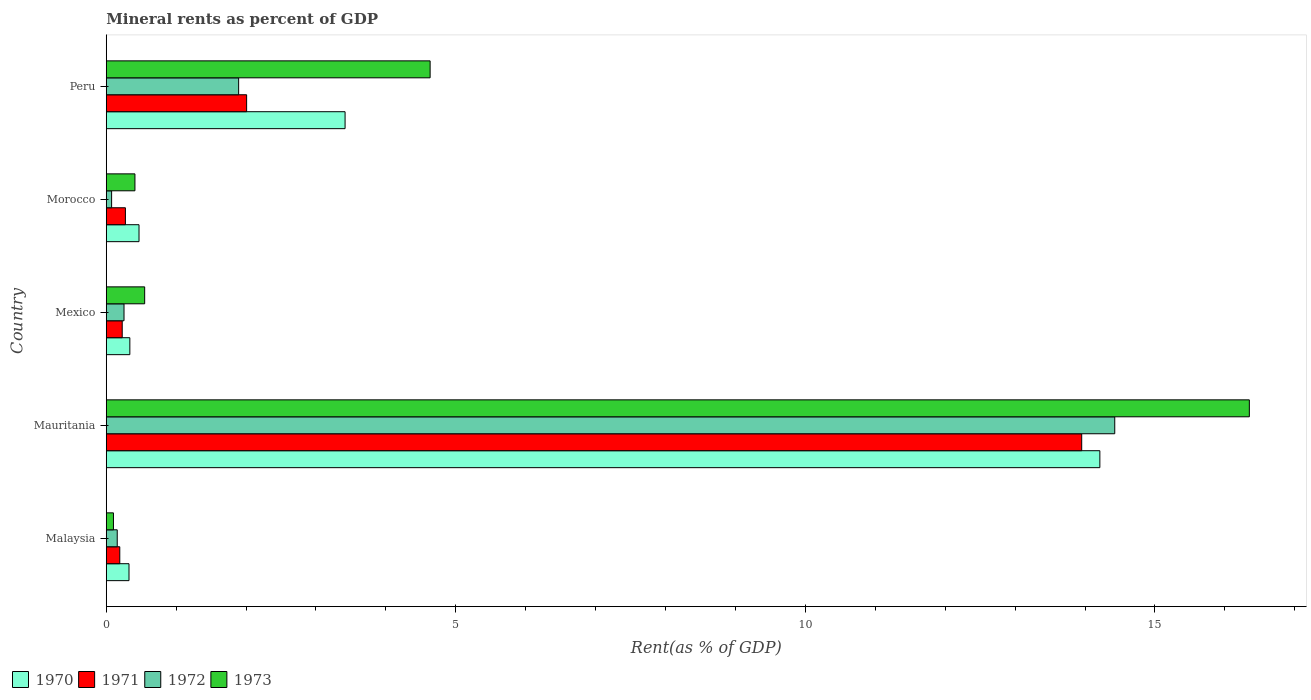How many groups of bars are there?
Your answer should be very brief. 5. Are the number of bars on each tick of the Y-axis equal?
Make the answer very short. Yes. How many bars are there on the 2nd tick from the top?
Offer a terse response. 4. What is the label of the 1st group of bars from the top?
Offer a very short reply. Peru. What is the mineral rent in 1971 in Mauritania?
Keep it short and to the point. 13.95. Across all countries, what is the maximum mineral rent in 1972?
Make the answer very short. 14.43. Across all countries, what is the minimum mineral rent in 1971?
Your answer should be compact. 0.19. In which country was the mineral rent in 1971 maximum?
Offer a terse response. Mauritania. In which country was the mineral rent in 1973 minimum?
Make the answer very short. Malaysia. What is the total mineral rent in 1973 in the graph?
Offer a terse response. 22.05. What is the difference between the mineral rent in 1972 in Malaysia and that in Mexico?
Offer a very short reply. -0.1. What is the difference between the mineral rent in 1971 in Mauritania and the mineral rent in 1973 in Peru?
Offer a terse response. 9.32. What is the average mineral rent in 1972 per country?
Give a very brief answer. 3.36. What is the difference between the mineral rent in 1973 and mineral rent in 1970 in Mauritania?
Ensure brevity in your answer.  2.14. In how many countries, is the mineral rent in 1971 greater than 8 %?
Ensure brevity in your answer.  1. What is the ratio of the mineral rent in 1973 in Morocco to that in Peru?
Provide a short and direct response. 0.09. Is the mineral rent in 1971 in Malaysia less than that in Peru?
Your answer should be very brief. Yes. Is the difference between the mineral rent in 1973 in Malaysia and Peru greater than the difference between the mineral rent in 1970 in Malaysia and Peru?
Your response must be concise. No. What is the difference between the highest and the second highest mineral rent in 1972?
Your answer should be very brief. 12.53. What is the difference between the highest and the lowest mineral rent in 1971?
Ensure brevity in your answer.  13.76. In how many countries, is the mineral rent in 1972 greater than the average mineral rent in 1972 taken over all countries?
Your answer should be compact. 1. Is the sum of the mineral rent in 1972 in Mauritania and Morocco greater than the maximum mineral rent in 1970 across all countries?
Provide a short and direct response. Yes. What does the 1st bar from the top in Mauritania represents?
Provide a succinct answer. 1973. What does the 4th bar from the bottom in Morocco represents?
Keep it short and to the point. 1973. How many countries are there in the graph?
Provide a short and direct response. 5. Does the graph contain any zero values?
Give a very brief answer. No. Does the graph contain grids?
Give a very brief answer. No. Where does the legend appear in the graph?
Your answer should be compact. Bottom left. How many legend labels are there?
Your response must be concise. 4. What is the title of the graph?
Your answer should be compact. Mineral rents as percent of GDP. Does "2009" appear as one of the legend labels in the graph?
Make the answer very short. No. What is the label or title of the X-axis?
Your answer should be very brief. Rent(as % of GDP). What is the Rent(as % of GDP) in 1970 in Malaysia?
Your answer should be compact. 0.33. What is the Rent(as % of GDP) of 1971 in Malaysia?
Make the answer very short. 0.19. What is the Rent(as % of GDP) in 1972 in Malaysia?
Offer a terse response. 0.16. What is the Rent(as % of GDP) in 1973 in Malaysia?
Ensure brevity in your answer.  0.1. What is the Rent(as % of GDP) of 1970 in Mauritania?
Your answer should be compact. 14.21. What is the Rent(as % of GDP) of 1971 in Mauritania?
Offer a very short reply. 13.95. What is the Rent(as % of GDP) of 1972 in Mauritania?
Keep it short and to the point. 14.43. What is the Rent(as % of GDP) in 1973 in Mauritania?
Provide a succinct answer. 16.35. What is the Rent(as % of GDP) of 1970 in Mexico?
Make the answer very short. 0.34. What is the Rent(as % of GDP) of 1971 in Mexico?
Provide a succinct answer. 0.23. What is the Rent(as % of GDP) of 1972 in Mexico?
Your response must be concise. 0.25. What is the Rent(as % of GDP) of 1973 in Mexico?
Provide a short and direct response. 0.55. What is the Rent(as % of GDP) in 1970 in Morocco?
Your answer should be compact. 0.47. What is the Rent(as % of GDP) in 1971 in Morocco?
Offer a terse response. 0.27. What is the Rent(as % of GDP) in 1972 in Morocco?
Provide a short and direct response. 0.08. What is the Rent(as % of GDP) in 1973 in Morocco?
Your response must be concise. 0.41. What is the Rent(as % of GDP) of 1970 in Peru?
Give a very brief answer. 3.42. What is the Rent(as % of GDP) in 1971 in Peru?
Provide a succinct answer. 2.01. What is the Rent(as % of GDP) of 1972 in Peru?
Provide a short and direct response. 1.89. What is the Rent(as % of GDP) of 1973 in Peru?
Your answer should be very brief. 4.63. Across all countries, what is the maximum Rent(as % of GDP) in 1970?
Your answer should be very brief. 14.21. Across all countries, what is the maximum Rent(as % of GDP) of 1971?
Offer a very short reply. 13.95. Across all countries, what is the maximum Rent(as % of GDP) in 1972?
Your response must be concise. 14.43. Across all countries, what is the maximum Rent(as % of GDP) of 1973?
Ensure brevity in your answer.  16.35. Across all countries, what is the minimum Rent(as % of GDP) of 1970?
Offer a very short reply. 0.33. Across all countries, what is the minimum Rent(as % of GDP) of 1971?
Give a very brief answer. 0.19. Across all countries, what is the minimum Rent(as % of GDP) in 1972?
Offer a terse response. 0.08. Across all countries, what is the minimum Rent(as % of GDP) in 1973?
Ensure brevity in your answer.  0.1. What is the total Rent(as % of GDP) in 1970 in the graph?
Your response must be concise. 18.76. What is the total Rent(as % of GDP) in 1971 in the graph?
Offer a very short reply. 16.66. What is the total Rent(as % of GDP) in 1972 in the graph?
Your answer should be very brief. 16.81. What is the total Rent(as % of GDP) in 1973 in the graph?
Provide a short and direct response. 22.05. What is the difference between the Rent(as % of GDP) of 1970 in Malaysia and that in Mauritania?
Your response must be concise. -13.89. What is the difference between the Rent(as % of GDP) of 1971 in Malaysia and that in Mauritania?
Keep it short and to the point. -13.76. What is the difference between the Rent(as % of GDP) of 1972 in Malaysia and that in Mauritania?
Your answer should be compact. -14.27. What is the difference between the Rent(as % of GDP) of 1973 in Malaysia and that in Mauritania?
Keep it short and to the point. -16.25. What is the difference between the Rent(as % of GDP) in 1970 in Malaysia and that in Mexico?
Ensure brevity in your answer.  -0.01. What is the difference between the Rent(as % of GDP) in 1971 in Malaysia and that in Mexico?
Give a very brief answer. -0.03. What is the difference between the Rent(as % of GDP) in 1972 in Malaysia and that in Mexico?
Provide a short and direct response. -0.1. What is the difference between the Rent(as % of GDP) in 1973 in Malaysia and that in Mexico?
Your answer should be very brief. -0.45. What is the difference between the Rent(as % of GDP) in 1970 in Malaysia and that in Morocco?
Provide a short and direct response. -0.14. What is the difference between the Rent(as % of GDP) of 1971 in Malaysia and that in Morocco?
Your response must be concise. -0.08. What is the difference between the Rent(as % of GDP) in 1972 in Malaysia and that in Morocco?
Ensure brevity in your answer.  0.08. What is the difference between the Rent(as % of GDP) of 1973 in Malaysia and that in Morocco?
Offer a very short reply. -0.31. What is the difference between the Rent(as % of GDP) of 1970 in Malaysia and that in Peru?
Your answer should be compact. -3.09. What is the difference between the Rent(as % of GDP) in 1971 in Malaysia and that in Peru?
Offer a very short reply. -1.81. What is the difference between the Rent(as % of GDP) of 1972 in Malaysia and that in Peru?
Your answer should be compact. -1.74. What is the difference between the Rent(as % of GDP) of 1973 in Malaysia and that in Peru?
Keep it short and to the point. -4.53. What is the difference between the Rent(as % of GDP) in 1970 in Mauritania and that in Mexico?
Make the answer very short. 13.88. What is the difference between the Rent(as % of GDP) of 1971 in Mauritania and that in Mexico?
Ensure brevity in your answer.  13.72. What is the difference between the Rent(as % of GDP) of 1972 in Mauritania and that in Mexico?
Provide a succinct answer. 14.17. What is the difference between the Rent(as % of GDP) of 1973 in Mauritania and that in Mexico?
Provide a short and direct response. 15.8. What is the difference between the Rent(as % of GDP) in 1970 in Mauritania and that in Morocco?
Give a very brief answer. 13.74. What is the difference between the Rent(as % of GDP) of 1971 in Mauritania and that in Morocco?
Your answer should be very brief. 13.68. What is the difference between the Rent(as % of GDP) of 1972 in Mauritania and that in Morocco?
Keep it short and to the point. 14.35. What is the difference between the Rent(as % of GDP) in 1973 in Mauritania and that in Morocco?
Give a very brief answer. 15.94. What is the difference between the Rent(as % of GDP) of 1970 in Mauritania and that in Peru?
Provide a short and direct response. 10.8. What is the difference between the Rent(as % of GDP) in 1971 in Mauritania and that in Peru?
Give a very brief answer. 11.94. What is the difference between the Rent(as % of GDP) of 1972 in Mauritania and that in Peru?
Provide a succinct answer. 12.53. What is the difference between the Rent(as % of GDP) in 1973 in Mauritania and that in Peru?
Your answer should be very brief. 11.72. What is the difference between the Rent(as % of GDP) in 1970 in Mexico and that in Morocco?
Your answer should be compact. -0.13. What is the difference between the Rent(as % of GDP) in 1971 in Mexico and that in Morocco?
Make the answer very short. -0.05. What is the difference between the Rent(as % of GDP) of 1972 in Mexico and that in Morocco?
Offer a terse response. 0.18. What is the difference between the Rent(as % of GDP) in 1973 in Mexico and that in Morocco?
Ensure brevity in your answer.  0.14. What is the difference between the Rent(as % of GDP) of 1970 in Mexico and that in Peru?
Offer a very short reply. -3.08. What is the difference between the Rent(as % of GDP) of 1971 in Mexico and that in Peru?
Provide a succinct answer. -1.78. What is the difference between the Rent(as % of GDP) in 1972 in Mexico and that in Peru?
Offer a terse response. -1.64. What is the difference between the Rent(as % of GDP) in 1973 in Mexico and that in Peru?
Offer a very short reply. -4.08. What is the difference between the Rent(as % of GDP) of 1970 in Morocco and that in Peru?
Give a very brief answer. -2.95. What is the difference between the Rent(as % of GDP) in 1971 in Morocco and that in Peru?
Your answer should be very brief. -1.73. What is the difference between the Rent(as % of GDP) of 1972 in Morocco and that in Peru?
Your response must be concise. -1.82. What is the difference between the Rent(as % of GDP) in 1973 in Morocco and that in Peru?
Offer a very short reply. -4.22. What is the difference between the Rent(as % of GDP) of 1970 in Malaysia and the Rent(as % of GDP) of 1971 in Mauritania?
Your response must be concise. -13.63. What is the difference between the Rent(as % of GDP) of 1970 in Malaysia and the Rent(as % of GDP) of 1972 in Mauritania?
Ensure brevity in your answer.  -14.1. What is the difference between the Rent(as % of GDP) in 1970 in Malaysia and the Rent(as % of GDP) in 1973 in Mauritania?
Your answer should be compact. -16.03. What is the difference between the Rent(as % of GDP) of 1971 in Malaysia and the Rent(as % of GDP) of 1972 in Mauritania?
Provide a succinct answer. -14.23. What is the difference between the Rent(as % of GDP) in 1971 in Malaysia and the Rent(as % of GDP) in 1973 in Mauritania?
Ensure brevity in your answer.  -16.16. What is the difference between the Rent(as % of GDP) in 1972 in Malaysia and the Rent(as % of GDP) in 1973 in Mauritania?
Provide a succinct answer. -16.19. What is the difference between the Rent(as % of GDP) of 1970 in Malaysia and the Rent(as % of GDP) of 1971 in Mexico?
Your answer should be very brief. 0.1. What is the difference between the Rent(as % of GDP) of 1970 in Malaysia and the Rent(as % of GDP) of 1972 in Mexico?
Your answer should be very brief. 0.07. What is the difference between the Rent(as % of GDP) in 1970 in Malaysia and the Rent(as % of GDP) in 1973 in Mexico?
Ensure brevity in your answer.  -0.22. What is the difference between the Rent(as % of GDP) in 1971 in Malaysia and the Rent(as % of GDP) in 1972 in Mexico?
Your answer should be very brief. -0.06. What is the difference between the Rent(as % of GDP) of 1971 in Malaysia and the Rent(as % of GDP) of 1973 in Mexico?
Offer a very short reply. -0.36. What is the difference between the Rent(as % of GDP) in 1972 in Malaysia and the Rent(as % of GDP) in 1973 in Mexico?
Provide a succinct answer. -0.39. What is the difference between the Rent(as % of GDP) in 1970 in Malaysia and the Rent(as % of GDP) in 1971 in Morocco?
Offer a very short reply. 0.05. What is the difference between the Rent(as % of GDP) of 1970 in Malaysia and the Rent(as % of GDP) of 1972 in Morocco?
Your answer should be very brief. 0.25. What is the difference between the Rent(as % of GDP) in 1970 in Malaysia and the Rent(as % of GDP) in 1973 in Morocco?
Your answer should be very brief. -0.09. What is the difference between the Rent(as % of GDP) in 1971 in Malaysia and the Rent(as % of GDP) in 1972 in Morocco?
Offer a terse response. 0.12. What is the difference between the Rent(as % of GDP) of 1971 in Malaysia and the Rent(as % of GDP) of 1973 in Morocco?
Provide a succinct answer. -0.22. What is the difference between the Rent(as % of GDP) of 1972 in Malaysia and the Rent(as % of GDP) of 1973 in Morocco?
Keep it short and to the point. -0.25. What is the difference between the Rent(as % of GDP) in 1970 in Malaysia and the Rent(as % of GDP) in 1971 in Peru?
Give a very brief answer. -1.68. What is the difference between the Rent(as % of GDP) of 1970 in Malaysia and the Rent(as % of GDP) of 1972 in Peru?
Your answer should be very brief. -1.57. What is the difference between the Rent(as % of GDP) in 1970 in Malaysia and the Rent(as % of GDP) in 1973 in Peru?
Ensure brevity in your answer.  -4.31. What is the difference between the Rent(as % of GDP) in 1971 in Malaysia and the Rent(as % of GDP) in 1972 in Peru?
Your answer should be compact. -1.7. What is the difference between the Rent(as % of GDP) in 1971 in Malaysia and the Rent(as % of GDP) in 1973 in Peru?
Offer a terse response. -4.44. What is the difference between the Rent(as % of GDP) in 1972 in Malaysia and the Rent(as % of GDP) in 1973 in Peru?
Offer a terse response. -4.48. What is the difference between the Rent(as % of GDP) of 1970 in Mauritania and the Rent(as % of GDP) of 1971 in Mexico?
Make the answer very short. 13.98. What is the difference between the Rent(as % of GDP) in 1970 in Mauritania and the Rent(as % of GDP) in 1972 in Mexico?
Offer a very short reply. 13.96. What is the difference between the Rent(as % of GDP) of 1970 in Mauritania and the Rent(as % of GDP) of 1973 in Mexico?
Offer a terse response. 13.66. What is the difference between the Rent(as % of GDP) of 1971 in Mauritania and the Rent(as % of GDP) of 1972 in Mexico?
Offer a terse response. 13.7. What is the difference between the Rent(as % of GDP) in 1971 in Mauritania and the Rent(as % of GDP) in 1973 in Mexico?
Offer a terse response. 13.4. What is the difference between the Rent(as % of GDP) of 1972 in Mauritania and the Rent(as % of GDP) of 1973 in Mexico?
Offer a very short reply. 13.88. What is the difference between the Rent(as % of GDP) in 1970 in Mauritania and the Rent(as % of GDP) in 1971 in Morocco?
Keep it short and to the point. 13.94. What is the difference between the Rent(as % of GDP) in 1970 in Mauritania and the Rent(as % of GDP) in 1972 in Morocco?
Offer a terse response. 14.14. What is the difference between the Rent(as % of GDP) of 1970 in Mauritania and the Rent(as % of GDP) of 1973 in Morocco?
Your answer should be compact. 13.8. What is the difference between the Rent(as % of GDP) in 1971 in Mauritania and the Rent(as % of GDP) in 1972 in Morocco?
Your answer should be very brief. 13.88. What is the difference between the Rent(as % of GDP) of 1971 in Mauritania and the Rent(as % of GDP) of 1973 in Morocco?
Ensure brevity in your answer.  13.54. What is the difference between the Rent(as % of GDP) of 1972 in Mauritania and the Rent(as % of GDP) of 1973 in Morocco?
Provide a succinct answer. 14.02. What is the difference between the Rent(as % of GDP) in 1970 in Mauritania and the Rent(as % of GDP) in 1971 in Peru?
Your response must be concise. 12.2. What is the difference between the Rent(as % of GDP) of 1970 in Mauritania and the Rent(as % of GDP) of 1972 in Peru?
Make the answer very short. 12.32. What is the difference between the Rent(as % of GDP) in 1970 in Mauritania and the Rent(as % of GDP) in 1973 in Peru?
Offer a very short reply. 9.58. What is the difference between the Rent(as % of GDP) of 1971 in Mauritania and the Rent(as % of GDP) of 1972 in Peru?
Your answer should be compact. 12.06. What is the difference between the Rent(as % of GDP) of 1971 in Mauritania and the Rent(as % of GDP) of 1973 in Peru?
Your answer should be compact. 9.32. What is the difference between the Rent(as % of GDP) of 1972 in Mauritania and the Rent(as % of GDP) of 1973 in Peru?
Offer a very short reply. 9.79. What is the difference between the Rent(as % of GDP) of 1970 in Mexico and the Rent(as % of GDP) of 1971 in Morocco?
Provide a succinct answer. 0.06. What is the difference between the Rent(as % of GDP) in 1970 in Mexico and the Rent(as % of GDP) in 1972 in Morocco?
Keep it short and to the point. 0.26. What is the difference between the Rent(as % of GDP) of 1970 in Mexico and the Rent(as % of GDP) of 1973 in Morocco?
Make the answer very short. -0.07. What is the difference between the Rent(as % of GDP) of 1971 in Mexico and the Rent(as % of GDP) of 1972 in Morocco?
Provide a succinct answer. 0.15. What is the difference between the Rent(as % of GDP) in 1971 in Mexico and the Rent(as % of GDP) in 1973 in Morocco?
Your answer should be very brief. -0.18. What is the difference between the Rent(as % of GDP) of 1972 in Mexico and the Rent(as % of GDP) of 1973 in Morocco?
Give a very brief answer. -0.16. What is the difference between the Rent(as % of GDP) in 1970 in Mexico and the Rent(as % of GDP) in 1971 in Peru?
Offer a very short reply. -1.67. What is the difference between the Rent(as % of GDP) of 1970 in Mexico and the Rent(as % of GDP) of 1972 in Peru?
Provide a short and direct response. -1.56. What is the difference between the Rent(as % of GDP) in 1970 in Mexico and the Rent(as % of GDP) in 1973 in Peru?
Keep it short and to the point. -4.29. What is the difference between the Rent(as % of GDP) of 1971 in Mexico and the Rent(as % of GDP) of 1972 in Peru?
Your answer should be very brief. -1.67. What is the difference between the Rent(as % of GDP) of 1971 in Mexico and the Rent(as % of GDP) of 1973 in Peru?
Your answer should be compact. -4.4. What is the difference between the Rent(as % of GDP) of 1972 in Mexico and the Rent(as % of GDP) of 1973 in Peru?
Your answer should be compact. -4.38. What is the difference between the Rent(as % of GDP) of 1970 in Morocco and the Rent(as % of GDP) of 1971 in Peru?
Keep it short and to the point. -1.54. What is the difference between the Rent(as % of GDP) in 1970 in Morocco and the Rent(as % of GDP) in 1972 in Peru?
Ensure brevity in your answer.  -1.43. What is the difference between the Rent(as % of GDP) in 1970 in Morocco and the Rent(as % of GDP) in 1973 in Peru?
Make the answer very short. -4.16. What is the difference between the Rent(as % of GDP) in 1971 in Morocco and the Rent(as % of GDP) in 1972 in Peru?
Make the answer very short. -1.62. What is the difference between the Rent(as % of GDP) in 1971 in Morocco and the Rent(as % of GDP) in 1973 in Peru?
Your answer should be compact. -4.36. What is the difference between the Rent(as % of GDP) in 1972 in Morocco and the Rent(as % of GDP) in 1973 in Peru?
Your response must be concise. -4.56. What is the average Rent(as % of GDP) in 1970 per country?
Give a very brief answer. 3.75. What is the average Rent(as % of GDP) of 1971 per country?
Ensure brevity in your answer.  3.33. What is the average Rent(as % of GDP) in 1972 per country?
Your response must be concise. 3.36. What is the average Rent(as % of GDP) in 1973 per country?
Provide a short and direct response. 4.41. What is the difference between the Rent(as % of GDP) of 1970 and Rent(as % of GDP) of 1971 in Malaysia?
Offer a terse response. 0.13. What is the difference between the Rent(as % of GDP) of 1970 and Rent(as % of GDP) of 1972 in Malaysia?
Your response must be concise. 0.17. What is the difference between the Rent(as % of GDP) in 1970 and Rent(as % of GDP) in 1973 in Malaysia?
Make the answer very short. 0.22. What is the difference between the Rent(as % of GDP) in 1971 and Rent(as % of GDP) in 1972 in Malaysia?
Offer a very short reply. 0.04. What is the difference between the Rent(as % of GDP) of 1971 and Rent(as % of GDP) of 1973 in Malaysia?
Provide a short and direct response. 0.09. What is the difference between the Rent(as % of GDP) of 1972 and Rent(as % of GDP) of 1973 in Malaysia?
Your answer should be compact. 0.05. What is the difference between the Rent(as % of GDP) of 1970 and Rent(as % of GDP) of 1971 in Mauritania?
Your answer should be very brief. 0.26. What is the difference between the Rent(as % of GDP) of 1970 and Rent(as % of GDP) of 1972 in Mauritania?
Make the answer very short. -0.21. What is the difference between the Rent(as % of GDP) in 1970 and Rent(as % of GDP) in 1973 in Mauritania?
Keep it short and to the point. -2.14. What is the difference between the Rent(as % of GDP) in 1971 and Rent(as % of GDP) in 1972 in Mauritania?
Give a very brief answer. -0.47. What is the difference between the Rent(as % of GDP) of 1971 and Rent(as % of GDP) of 1973 in Mauritania?
Give a very brief answer. -2.4. What is the difference between the Rent(as % of GDP) of 1972 and Rent(as % of GDP) of 1973 in Mauritania?
Your answer should be compact. -1.93. What is the difference between the Rent(as % of GDP) of 1970 and Rent(as % of GDP) of 1971 in Mexico?
Your response must be concise. 0.11. What is the difference between the Rent(as % of GDP) in 1970 and Rent(as % of GDP) in 1972 in Mexico?
Give a very brief answer. 0.08. What is the difference between the Rent(as % of GDP) of 1970 and Rent(as % of GDP) of 1973 in Mexico?
Make the answer very short. -0.21. What is the difference between the Rent(as % of GDP) of 1971 and Rent(as % of GDP) of 1972 in Mexico?
Offer a very short reply. -0.03. What is the difference between the Rent(as % of GDP) of 1971 and Rent(as % of GDP) of 1973 in Mexico?
Offer a terse response. -0.32. What is the difference between the Rent(as % of GDP) of 1972 and Rent(as % of GDP) of 1973 in Mexico?
Provide a short and direct response. -0.3. What is the difference between the Rent(as % of GDP) in 1970 and Rent(as % of GDP) in 1971 in Morocco?
Keep it short and to the point. 0.19. What is the difference between the Rent(as % of GDP) of 1970 and Rent(as % of GDP) of 1972 in Morocco?
Your response must be concise. 0.39. What is the difference between the Rent(as % of GDP) of 1970 and Rent(as % of GDP) of 1973 in Morocco?
Offer a very short reply. 0.06. What is the difference between the Rent(as % of GDP) in 1971 and Rent(as % of GDP) in 1972 in Morocco?
Keep it short and to the point. 0.2. What is the difference between the Rent(as % of GDP) in 1971 and Rent(as % of GDP) in 1973 in Morocco?
Your response must be concise. -0.14. What is the difference between the Rent(as % of GDP) in 1972 and Rent(as % of GDP) in 1973 in Morocco?
Ensure brevity in your answer.  -0.33. What is the difference between the Rent(as % of GDP) of 1970 and Rent(as % of GDP) of 1971 in Peru?
Offer a very short reply. 1.41. What is the difference between the Rent(as % of GDP) in 1970 and Rent(as % of GDP) in 1972 in Peru?
Give a very brief answer. 1.52. What is the difference between the Rent(as % of GDP) of 1970 and Rent(as % of GDP) of 1973 in Peru?
Your answer should be compact. -1.22. What is the difference between the Rent(as % of GDP) in 1971 and Rent(as % of GDP) in 1972 in Peru?
Provide a short and direct response. 0.11. What is the difference between the Rent(as % of GDP) in 1971 and Rent(as % of GDP) in 1973 in Peru?
Offer a very short reply. -2.62. What is the difference between the Rent(as % of GDP) of 1972 and Rent(as % of GDP) of 1973 in Peru?
Give a very brief answer. -2.74. What is the ratio of the Rent(as % of GDP) in 1970 in Malaysia to that in Mauritania?
Make the answer very short. 0.02. What is the ratio of the Rent(as % of GDP) of 1971 in Malaysia to that in Mauritania?
Your answer should be compact. 0.01. What is the ratio of the Rent(as % of GDP) in 1972 in Malaysia to that in Mauritania?
Your response must be concise. 0.01. What is the ratio of the Rent(as % of GDP) of 1973 in Malaysia to that in Mauritania?
Give a very brief answer. 0.01. What is the ratio of the Rent(as % of GDP) in 1970 in Malaysia to that in Mexico?
Keep it short and to the point. 0.96. What is the ratio of the Rent(as % of GDP) in 1971 in Malaysia to that in Mexico?
Keep it short and to the point. 0.85. What is the ratio of the Rent(as % of GDP) of 1972 in Malaysia to that in Mexico?
Give a very brief answer. 0.62. What is the ratio of the Rent(as % of GDP) in 1973 in Malaysia to that in Mexico?
Your answer should be very brief. 0.19. What is the ratio of the Rent(as % of GDP) in 1970 in Malaysia to that in Morocco?
Provide a short and direct response. 0.69. What is the ratio of the Rent(as % of GDP) of 1971 in Malaysia to that in Morocco?
Keep it short and to the point. 0.71. What is the ratio of the Rent(as % of GDP) of 1972 in Malaysia to that in Morocco?
Your response must be concise. 2.04. What is the ratio of the Rent(as % of GDP) in 1973 in Malaysia to that in Morocco?
Your response must be concise. 0.25. What is the ratio of the Rent(as % of GDP) of 1970 in Malaysia to that in Peru?
Your response must be concise. 0.1. What is the ratio of the Rent(as % of GDP) in 1971 in Malaysia to that in Peru?
Your response must be concise. 0.1. What is the ratio of the Rent(as % of GDP) of 1972 in Malaysia to that in Peru?
Your answer should be very brief. 0.08. What is the ratio of the Rent(as % of GDP) in 1973 in Malaysia to that in Peru?
Provide a succinct answer. 0.02. What is the ratio of the Rent(as % of GDP) in 1970 in Mauritania to that in Mexico?
Your answer should be very brief. 42.1. What is the ratio of the Rent(as % of GDP) in 1971 in Mauritania to that in Mexico?
Give a very brief answer. 61.1. What is the ratio of the Rent(as % of GDP) of 1972 in Mauritania to that in Mexico?
Provide a succinct answer. 56.78. What is the ratio of the Rent(as % of GDP) of 1973 in Mauritania to that in Mexico?
Your answer should be very brief. 29.75. What is the ratio of the Rent(as % of GDP) in 1970 in Mauritania to that in Morocco?
Your answer should be very brief. 30.32. What is the ratio of the Rent(as % of GDP) in 1971 in Mauritania to that in Morocco?
Make the answer very short. 50.9. What is the ratio of the Rent(as % of GDP) of 1972 in Mauritania to that in Morocco?
Your response must be concise. 187.82. What is the ratio of the Rent(as % of GDP) in 1973 in Mauritania to that in Morocco?
Provide a short and direct response. 39.85. What is the ratio of the Rent(as % of GDP) of 1970 in Mauritania to that in Peru?
Make the answer very short. 4.16. What is the ratio of the Rent(as % of GDP) of 1971 in Mauritania to that in Peru?
Your answer should be compact. 6.95. What is the ratio of the Rent(as % of GDP) in 1972 in Mauritania to that in Peru?
Your answer should be compact. 7.62. What is the ratio of the Rent(as % of GDP) of 1973 in Mauritania to that in Peru?
Provide a succinct answer. 3.53. What is the ratio of the Rent(as % of GDP) in 1970 in Mexico to that in Morocco?
Your answer should be compact. 0.72. What is the ratio of the Rent(as % of GDP) in 1971 in Mexico to that in Morocco?
Your answer should be compact. 0.83. What is the ratio of the Rent(as % of GDP) in 1972 in Mexico to that in Morocco?
Your answer should be very brief. 3.31. What is the ratio of the Rent(as % of GDP) of 1973 in Mexico to that in Morocco?
Provide a short and direct response. 1.34. What is the ratio of the Rent(as % of GDP) of 1970 in Mexico to that in Peru?
Ensure brevity in your answer.  0.1. What is the ratio of the Rent(as % of GDP) in 1971 in Mexico to that in Peru?
Offer a terse response. 0.11. What is the ratio of the Rent(as % of GDP) in 1972 in Mexico to that in Peru?
Offer a very short reply. 0.13. What is the ratio of the Rent(as % of GDP) of 1973 in Mexico to that in Peru?
Your answer should be compact. 0.12. What is the ratio of the Rent(as % of GDP) in 1970 in Morocco to that in Peru?
Ensure brevity in your answer.  0.14. What is the ratio of the Rent(as % of GDP) of 1971 in Morocco to that in Peru?
Your response must be concise. 0.14. What is the ratio of the Rent(as % of GDP) of 1972 in Morocco to that in Peru?
Offer a terse response. 0.04. What is the ratio of the Rent(as % of GDP) of 1973 in Morocco to that in Peru?
Provide a succinct answer. 0.09. What is the difference between the highest and the second highest Rent(as % of GDP) of 1970?
Ensure brevity in your answer.  10.8. What is the difference between the highest and the second highest Rent(as % of GDP) in 1971?
Ensure brevity in your answer.  11.94. What is the difference between the highest and the second highest Rent(as % of GDP) of 1972?
Offer a terse response. 12.53. What is the difference between the highest and the second highest Rent(as % of GDP) of 1973?
Provide a short and direct response. 11.72. What is the difference between the highest and the lowest Rent(as % of GDP) of 1970?
Provide a short and direct response. 13.89. What is the difference between the highest and the lowest Rent(as % of GDP) in 1971?
Your response must be concise. 13.76. What is the difference between the highest and the lowest Rent(as % of GDP) in 1972?
Provide a succinct answer. 14.35. What is the difference between the highest and the lowest Rent(as % of GDP) in 1973?
Give a very brief answer. 16.25. 